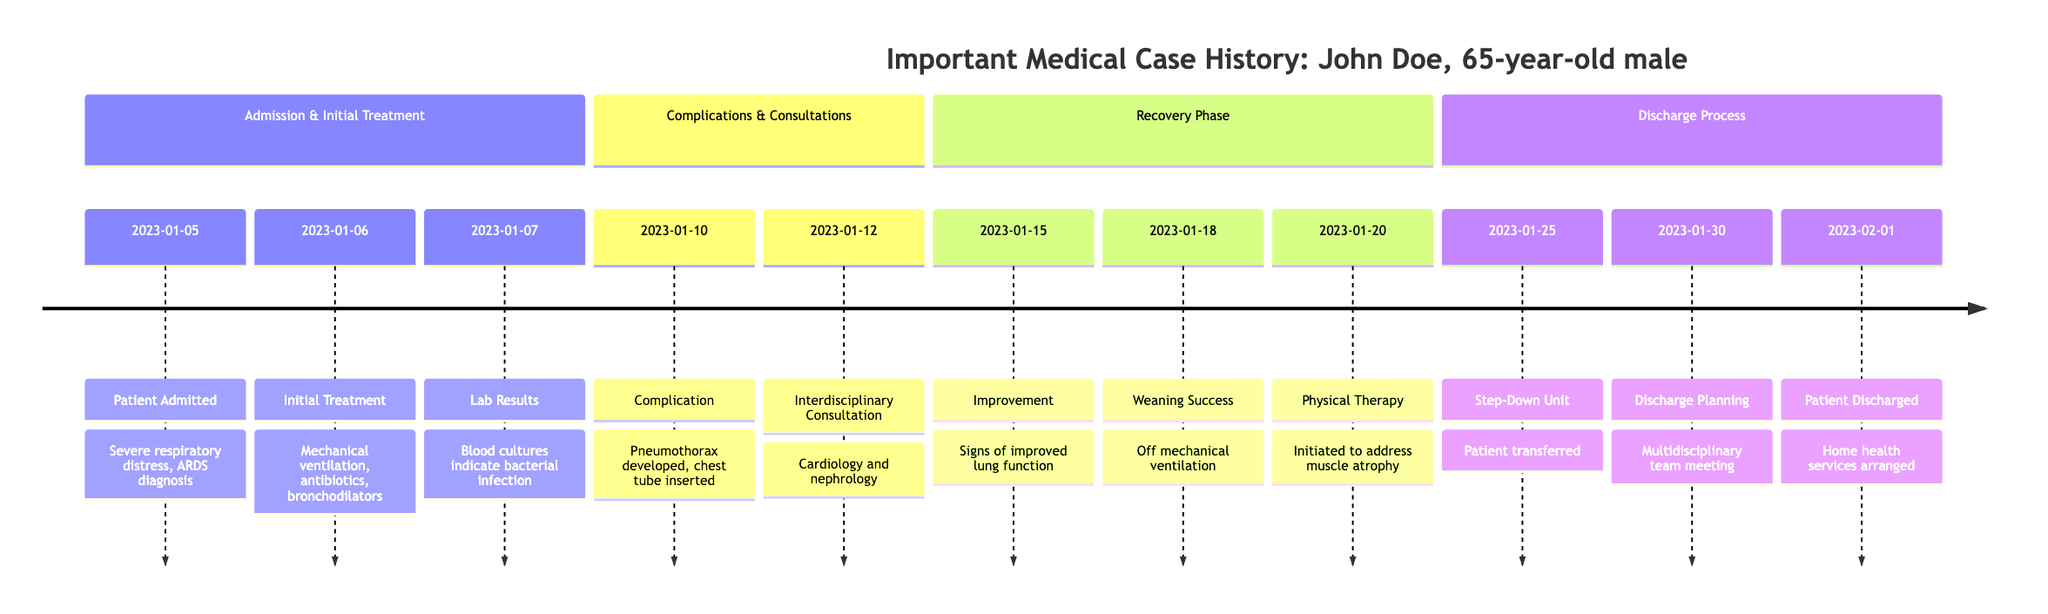What is the initial diagnosis for John Doe upon admission? The diagram explicitly states that John Doe was diagnosed with Acute Respiratory Distress Syndrome (ARDS) upon his admission on January 5, 2023.
Answer: Acute Respiratory Distress Syndrome (ARDS) What date did John Doe develop a pneumothorax? The timeline shows that John Doe developed a pneumothorax on January 10, 2023.
Answer: January 10, 2023 How many days was John Doe on mechanical ventilation? John Doe was placed on mechanical ventilation on January 6 and successfully weaned off on January 18, which totals 12 days (from January 6 to January 18 inclusive).
Answer: 12 days What type of therapy did John Doe start on January 20? The timeline indicates that physical therapy was initiated on January 20, 2023, to address muscle atrophy.
Answer: Physical therapy Which specialties were consulted on January 12, 2023? The diagram specifies that there was an interdisciplinary consultation involving cardiology and nephrology on January 12, 2023.
Answer: Cardiology and nephrology What was the outcome after the initial improvement on January 15? Following the improvement noted on January 15, the timeline indicates that John Doe was successfully weaned off mechanical ventilation on January 18, meaning that his lung function continued to improve.
Answer: Successfully weaned off mechanical ventilation How many events are listed in the recovery phase of the timeline? The recovery phase contains 3 events: Improvement on January 15, Weaning Success on January 18, and Physical Therapy initiated on January 20.
Answer: 3 events What significant team meeting occurred on January 30? The timeline specifies a multidisciplinary team meeting for discharge planning that took place on January 30, 2023.
Answer: Multidisciplinary team meeting When was John Doe discharged from the ICU? John Doe was discharged from the ICU on February 1, 2023, as shown in the timeline.
Answer: February 1, 2023 